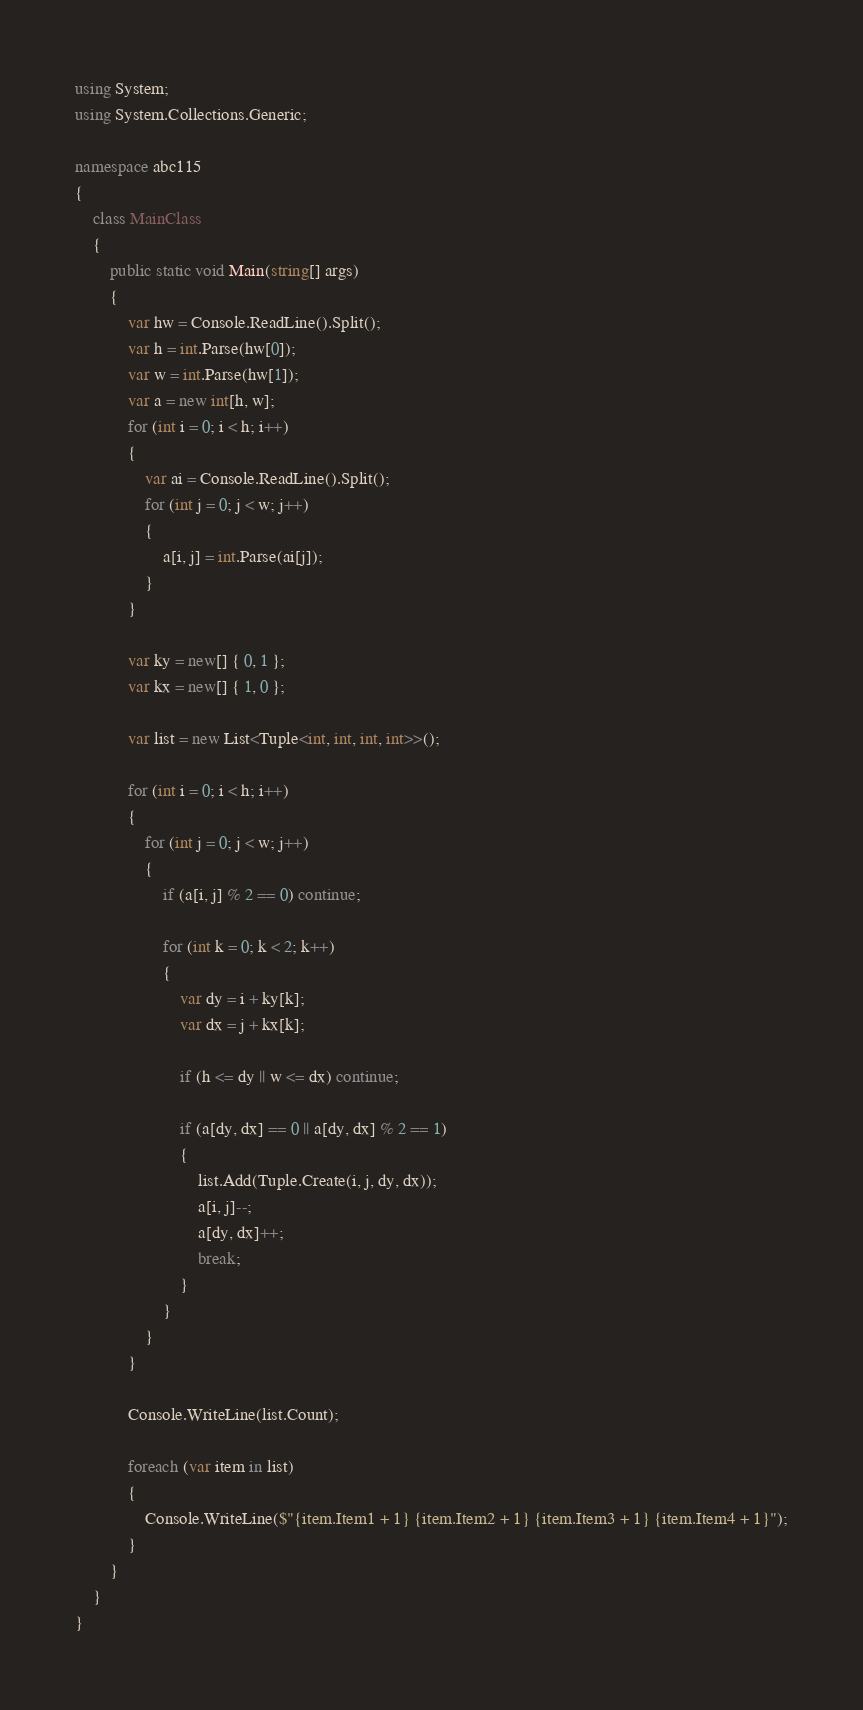Convert code to text. <code><loc_0><loc_0><loc_500><loc_500><_C#_>using System;
using System.Collections.Generic;

namespace abc115
{
    class MainClass
    {
        public static void Main(string[] args)
        {
            var hw = Console.ReadLine().Split();
            var h = int.Parse(hw[0]);
            var w = int.Parse(hw[1]);
            var a = new int[h, w];
            for (int i = 0; i < h; i++)
            {
                var ai = Console.ReadLine().Split();
                for (int j = 0; j < w; j++)
                {
                    a[i, j] = int.Parse(ai[j]);
                }
            }

            var ky = new[] { 0, 1 };
            var kx = new[] { 1, 0 };

            var list = new List<Tuple<int, int, int, int>>();

            for (int i = 0; i < h; i++)
            {
                for (int j = 0; j < w; j++)
                {
                    if (a[i, j] % 2 == 0) continue;

                    for (int k = 0; k < 2; k++)
                    {
                        var dy = i + ky[k];
                        var dx = j + kx[k];

                        if (h <= dy || w <= dx) continue;

                        if (a[dy, dx] == 0 || a[dy, dx] % 2 == 1)
                        {
                            list.Add(Tuple.Create(i, j, dy, dx));
                            a[i, j]--;
                            a[dy, dx]++;
                            break;
                        }
                    }
                }
            }

            Console.WriteLine(list.Count);

            foreach (var item in list)
            {
                Console.WriteLine($"{item.Item1 + 1} {item.Item2 + 1} {item.Item3 + 1} {item.Item4 + 1}");
            }
        }
    }
}
</code> 